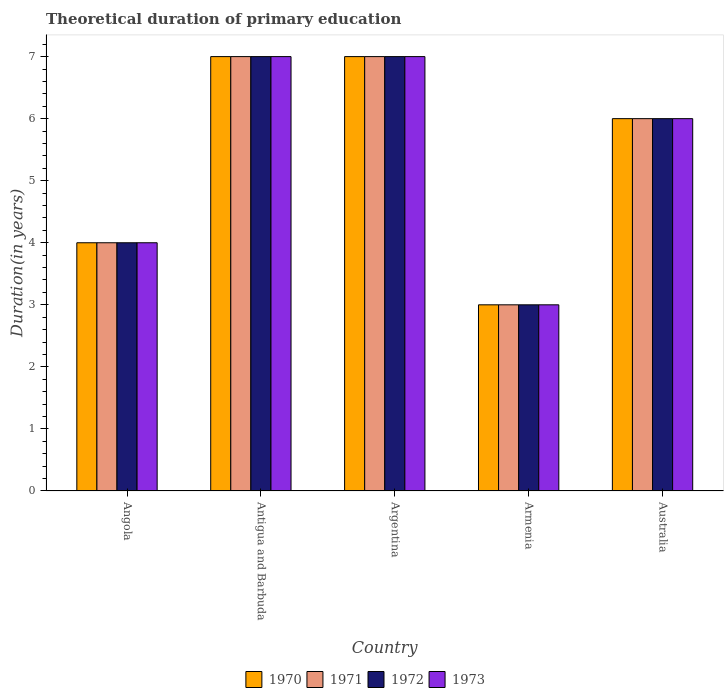How many different coloured bars are there?
Your response must be concise. 4. How many groups of bars are there?
Give a very brief answer. 5. Are the number of bars per tick equal to the number of legend labels?
Your response must be concise. Yes. How many bars are there on the 4th tick from the left?
Offer a terse response. 4. What is the label of the 2nd group of bars from the left?
Offer a terse response. Antigua and Barbuda. In how many cases, is the number of bars for a given country not equal to the number of legend labels?
Offer a terse response. 0. In which country was the total theoretical duration of primary education in 1973 maximum?
Provide a succinct answer. Antigua and Barbuda. In which country was the total theoretical duration of primary education in 1973 minimum?
Offer a very short reply. Armenia. In how many countries, is the total theoretical duration of primary education in 1972 greater than 6.6 years?
Your response must be concise. 2. Is the total theoretical duration of primary education in 1972 in Angola less than that in Argentina?
Your answer should be compact. Yes. What is the difference between the highest and the second highest total theoretical duration of primary education in 1972?
Keep it short and to the point. -1. Is the sum of the total theoretical duration of primary education in 1973 in Angola and Argentina greater than the maximum total theoretical duration of primary education in 1970 across all countries?
Give a very brief answer. Yes. Is it the case that in every country, the sum of the total theoretical duration of primary education in 1973 and total theoretical duration of primary education in 1971 is greater than the total theoretical duration of primary education in 1970?
Ensure brevity in your answer.  Yes. How many bars are there?
Ensure brevity in your answer.  20. What is the difference between two consecutive major ticks on the Y-axis?
Your response must be concise. 1. Are the values on the major ticks of Y-axis written in scientific E-notation?
Keep it short and to the point. No. Does the graph contain any zero values?
Make the answer very short. No. How are the legend labels stacked?
Offer a very short reply. Horizontal. What is the title of the graph?
Offer a terse response. Theoretical duration of primary education. What is the label or title of the X-axis?
Provide a short and direct response. Country. What is the label or title of the Y-axis?
Your answer should be very brief. Duration(in years). What is the Duration(in years) of 1972 in Angola?
Make the answer very short. 4. What is the Duration(in years) in 1973 in Angola?
Ensure brevity in your answer.  4. What is the Duration(in years) in 1971 in Antigua and Barbuda?
Make the answer very short. 7. What is the Duration(in years) of 1972 in Antigua and Barbuda?
Make the answer very short. 7. What is the Duration(in years) in 1973 in Antigua and Barbuda?
Make the answer very short. 7. What is the Duration(in years) of 1972 in Argentina?
Your answer should be compact. 7. What is the Duration(in years) of 1973 in Argentina?
Give a very brief answer. 7. What is the Duration(in years) of 1970 in Armenia?
Give a very brief answer. 3. What is the Duration(in years) in 1971 in Armenia?
Keep it short and to the point. 3. What is the Duration(in years) in 1972 in Armenia?
Give a very brief answer. 3. What is the Duration(in years) in 1973 in Armenia?
Your answer should be compact. 3. What is the Duration(in years) of 1970 in Australia?
Provide a succinct answer. 6. What is the Duration(in years) in 1971 in Australia?
Your response must be concise. 6. Across all countries, what is the maximum Duration(in years) in 1970?
Provide a succinct answer. 7. Across all countries, what is the maximum Duration(in years) in 1972?
Offer a very short reply. 7. Across all countries, what is the minimum Duration(in years) in 1972?
Your response must be concise. 3. What is the total Duration(in years) in 1971 in the graph?
Make the answer very short. 27. What is the total Duration(in years) of 1973 in the graph?
Offer a very short reply. 27. What is the difference between the Duration(in years) of 1970 in Angola and that in Antigua and Barbuda?
Ensure brevity in your answer.  -3. What is the difference between the Duration(in years) of 1972 in Angola and that in Antigua and Barbuda?
Give a very brief answer. -3. What is the difference between the Duration(in years) in 1970 in Angola and that in Argentina?
Your answer should be very brief. -3. What is the difference between the Duration(in years) in 1972 in Angola and that in Argentina?
Keep it short and to the point. -3. What is the difference between the Duration(in years) of 1972 in Angola and that in Armenia?
Your answer should be very brief. 1. What is the difference between the Duration(in years) in 1971 in Angola and that in Australia?
Your answer should be very brief. -2. What is the difference between the Duration(in years) of 1971 in Antigua and Barbuda and that in Argentina?
Your response must be concise. 0. What is the difference between the Duration(in years) in 1972 in Antigua and Barbuda and that in Armenia?
Give a very brief answer. 4. What is the difference between the Duration(in years) in 1970 in Antigua and Barbuda and that in Australia?
Keep it short and to the point. 1. What is the difference between the Duration(in years) of 1971 in Antigua and Barbuda and that in Australia?
Give a very brief answer. 1. What is the difference between the Duration(in years) of 1972 in Antigua and Barbuda and that in Australia?
Your answer should be very brief. 1. What is the difference between the Duration(in years) of 1973 in Antigua and Barbuda and that in Australia?
Provide a short and direct response. 1. What is the difference between the Duration(in years) in 1971 in Argentina and that in Armenia?
Make the answer very short. 4. What is the difference between the Duration(in years) in 1972 in Argentina and that in Armenia?
Ensure brevity in your answer.  4. What is the difference between the Duration(in years) of 1972 in Argentina and that in Australia?
Ensure brevity in your answer.  1. What is the difference between the Duration(in years) of 1970 in Armenia and that in Australia?
Offer a very short reply. -3. What is the difference between the Duration(in years) in 1971 in Armenia and that in Australia?
Offer a very short reply. -3. What is the difference between the Duration(in years) in 1972 in Armenia and that in Australia?
Give a very brief answer. -3. What is the difference between the Duration(in years) of 1970 in Angola and the Duration(in years) of 1972 in Antigua and Barbuda?
Ensure brevity in your answer.  -3. What is the difference between the Duration(in years) in 1971 in Angola and the Duration(in years) in 1972 in Antigua and Barbuda?
Provide a succinct answer. -3. What is the difference between the Duration(in years) in 1971 in Angola and the Duration(in years) in 1973 in Antigua and Barbuda?
Give a very brief answer. -3. What is the difference between the Duration(in years) in 1972 in Angola and the Duration(in years) in 1973 in Antigua and Barbuda?
Offer a very short reply. -3. What is the difference between the Duration(in years) in 1970 in Angola and the Duration(in years) in 1971 in Argentina?
Provide a succinct answer. -3. What is the difference between the Duration(in years) of 1970 in Angola and the Duration(in years) of 1972 in Argentina?
Keep it short and to the point. -3. What is the difference between the Duration(in years) of 1971 in Angola and the Duration(in years) of 1973 in Argentina?
Ensure brevity in your answer.  -3. What is the difference between the Duration(in years) of 1970 in Angola and the Duration(in years) of 1971 in Armenia?
Ensure brevity in your answer.  1. What is the difference between the Duration(in years) in 1970 in Angola and the Duration(in years) in 1973 in Armenia?
Your answer should be very brief. 1. What is the difference between the Duration(in years) of 1972 in Angola and the Duration(in years) of 1973 in Armenia?
Give a very brief answer. 1. What is the difference between the Duration(in years) in 1970 in Angola and the Duration(in years) in 1971 in Australia?
Give a very brief answer. -2. What is the difference between the Duration(in years) in 1970 in Angola and the Duration(in years) in 1973 in Australia?
Offer a terse response. -2. What is the difference between the Duration(in years) of 1971 in Angola and the Duration(in years) of 1972 in Australia?
Keep it short and to the point. -2. What is the difference between the Duration(in years) in 1971 in Angola and the Duration(in years) in 1973 in Australia?
Your answer should be compact. -2. What is the difference between the Duration(in years) in 1971 in Antigua and Barbuda and the Duration(in years) in 1972 in Argentina?
Your answer should be very brief. 0. What is the difference between the Duration(in years) of 1971 in Antigua and Barbuda and the Duration(in years) of 1973 in Argentina?
Provide a succinct answer. 0. What is the difference between the Duration(in years) in 1972 in Antigua and Barbuda and the Duration(in years) in 1973 in Argentina?
Keep it short and to the point. 0. What is the difference between the Duration(in years) in 1970 in Antigua and Barbuda and the Duration(in years) in 1973 in Armenia?
Provide a short and direct response. 4. What is the difference between the Duration(in years) in 1971 in Antigua and Barbuda and the Duration(in years) in 1972 in Armenia?
Offer a terse response. 4. What is the difference between the Duration(in years) of 1972 in Antigua and Barbuda and the Duration(in years) of 1973 in Armenia?
Keep it short and to the point. 4. What is the difference between the Duration(in years) in 1970 in Antigua and Barbuda and the Duration(in years) in 1972 in Australia?
Provide a short and direct response. 1. What is the difference between the Duration(in years) in 1971 in Antigua and Barbuda and the Duration(in years) in 1972 in Australia?
Offer a terse response. 1. What is the difference between the Duration(in years) of 1970 in Argentina and the Duration(in years) of 1971 in Armenia?
Give a very brief answer. 4. What is the difference between the Duration(in years) in 1970 in Argentina and the Duration(in years) in 1972 in Armenia?
Provide a short and direct response. 4. What is the difference between the Duration(in years) in 1970 in Argentina and the Duration(in years) in 1973 in Armenia?
Offer a terse response. 4. What is the difference between the Duration(in years) of 1971 in Argentina and the Duration(in years) of 1973 in Armenia?
Your answer should be compact. 4. What is the difference between the Duration(in years) in 1972 in Argentina and the Duration(in years) in 1973 in Armenia?
Make the answer very short. 4. What is the difference between the Duration(in years) in 1970 in Argentina and the Duration(in years) in 1972 in Australia?
Your response must be concise. 1. What is the difference between the Duration(in years) of 1971 in Argentina and the Duration(in years) of 1972 in Australia?
Your response must be concise. 1. What is the difference between the Duration(in years) in 1971 in Argentina and the Duration(in years) in 1973 in Australia?
Your answer should be compact. 1. What is the difference between the Duration(in years) of 1972 in Argentina and the Duration(in years) of 1973 in Australia?
Keep it short and to the point. 1. What is the difference between the Duration(in years) of 1970 in Armenia and the Duration(in years) of 1971 in Australia?
Provide a succinct answer. -3. What is the difference between the Duration(in years) in 1970 in Armenia and the Duration(in years) in 1973 in Australia?
Your answer should be very brief. -3. What is the difference between the Duration(in years) in 1971 in Armenia and the Duration(in years) in 1972 in Australia?
Ensure brevity in your answer.  -3. What is the average Duration(in years) in 1971 per country?
Make the answer very short. 5.4. What is the average Duration(in years) of 1973 per country?
Offer a very short reply. 5.4. What is the difference between the Duration(in years) of 1970 and Duration(in years) of 1971 in Angola?
Give a very brief answer. 0. What is the difference between the Duration(in years) of 1970 and Duration(in years) of 1972 in Angola?
Make the answer very short. 0. What is the difference between the Duration(in years) of 1971 and Duration(in years) of 1972 in Angola?
Your answer should be compact. 0. What is the difference between the Duration(in years) in 1971 and Duration(in years) in 1973 in Angola?
Your answer should be compact. 0. What is the difference between the Duration(in years) in 1970 and Duration(in years) in 1972 in Antigua and Barbuda?
Give a very brief answer. 0. What is the difference between the Duration(in years) in 1970 and Duration(in years) in 1973 in Antigua and Barbuda?
Make the answer very short. 0. What is the difference between the Duration(in years) of 1971 and Duration(in years) of 1972 in Antigua and Barbuda?
Your response must be concise. 0. What is the difference between the Duration(in years) of 1971 and Duration(in years) of 1972 in Argentina?
Ensure brevity in your answer.  0. What is the difference between the Duration(in years) in 1971 and Duration(in years) in 1973 in Argentina?
Ensure brevity in your answer.  0. What is the difference between the Duration(in years) in 1972 and Duration(in years) in 1973 in Argentina?
Make the answer very short. 0. What is the difference between the Duration(in years) of 1970 and Duration(in years) of 1971 in Armenia?
Give a very brief answer. 0. What is the difference between the Duration(in years) in 1970 and Duration(in years) in 1972 in Armenia?
Ensure brevity in your answer.  0. What is the difference between the Duration(in years) in 1970 and Duration(in years) in 1973 in Armenia?
Ensure brevity in your answer.  0. What is the difference between the Duration(in years) in 1971 and Duration(in years) in 1972 in Armenia?
Your answer should be compact. 0. What is the difference between the Duration(in years) in 1970 and Duration(in years) in 1971 in Australia?
Offer a terse response. 0. What is the difference between the Duration(in years) of 1970 and Duration(in years) of 1973 in Australia?
Keep it short and to the point. 0. What is the difference between the Duration(in years) of 1972 and Duration(in years) of 1973 in Australia?
Keep it short and to the point. 0. What is the ratio of the Duration(in years) of 1970 in Antigua and Barbuda to that in Argentina?
Give a very brief answer. 1. What is the ratio of the Duration(in years) of 1972 in Antigua and Barbuda to that in Argentina?
Make the answer very short. 1. What is the ratio of the Duration(in years) of 1973 in Antigua and Barbuda to that in Argentina?
Ensure brevity in your answer.  1. What is the ratio of the Duration(in years) of 1970 in Antigua and Barbuda to that in Armenia?
Keep it short and to the point. 2.33. What is the ratio of the Duration(in years) of 1971 in Antigua and Barbuda to that in Armenia?
Make the answer very short. 2.33. What is the ratio of the Duration(in years) in 1972 in Antigua and Barbuda to that in Armenia?
Provide a succinct answer. 2.33. What is the ratio of the Duration(in years) of 1973 in Antigua and Barbuda to that in Armenia?
Your response must be concise. 2.33. What is the ratio of the Duration(in years) in 1973 in Antigua and Barbuda to that in Australia?
Keep it short and to the point. 1.17. What is the ratio of the Duration(in years) of 1970 in Argentina to that in Armenia?
Your answer should be compact. 2.33. What is the ratio of the Duration(in years) in 1971 in Argentina to that in Armenia?
Your answer should be very brief. 2.33. What is the ratio of the Duration(in years) in 1972 in Argentina to that in Armenia?
Give a very brief answer. 2.33. What is the ratio of the Duration(in years) of 1973 in Argentina to that in Armenia?
Ensure brevity in your answer.  2.33. What is the ratio of the Duration(in years) in 1972 in Argentina to that in Australia?
Your answer should be very brief. 1.17. What is the ratio of the Duration(in years) of 1973 in Argentina to that in Australia?
Your answer should be compact. 1.17. What is the ratio of the Duration(in years) in 1972 in Armenia to that in Australia?
Your answer should be compact. 0.5. What is the difference between the highest and the second highest Duration(in years) in 1971?
Your response must be concise. 0. What is the difference between the highest and the second highest Duration(in years) of 1972?
Your answer should be very brief. 0. What is the difference between the highest and the second highest Duration(in years) of 1973?
Offer a terse response. 0. What is the difference between the highest and the lowest Duration(in years) in 1970?
Offer a terse response. 4. What is the difference between the highest and the lowest Duration(in years) in 1971?
Make the answer very short. 4. What is the difference between the highest and the lowest Duration(in years) in 1972?
Give a very brief answer. 4. What is the difference between the highest and the lowest Duration(in years) of 1973?
Your answer should be compact. 4. 